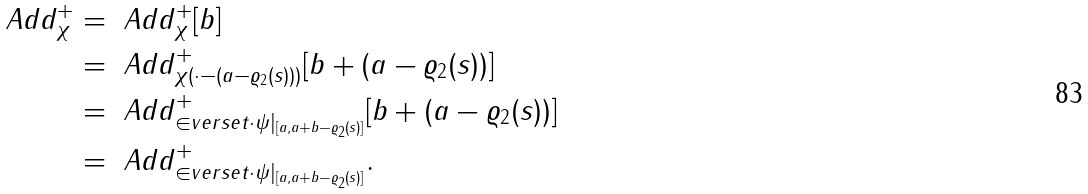<formula> <loc_0><loc_0><loc_500><loc_500>\ A d d ^ { + } _ { \chi } & = \ A d d ^ { + } _ { \chi } [ b ] \\ & = \ A d d ^ { + } _ { \chi ( \cdot - ( a - \varrho _ { 2 } ( s ) ) ) } [ b + ( a - \varrho _ { 2 } ( s ) ) ] \\ & = \ A d d ^ { + } _ { \in v e r s e { t \cdot \psi | _ { [ a , a + b - \varrho _ { 2 } ( s ) ] } } } [ b + ( a - \varrho _ { 2 } ( s ) ) ] \\ & = \ A d d ^ { + } _ { \in v e r s e { t \cdot \psi | _ { [ a , a + b - \varrho _ { 2 } ( s ) ] } } } .</formula> 